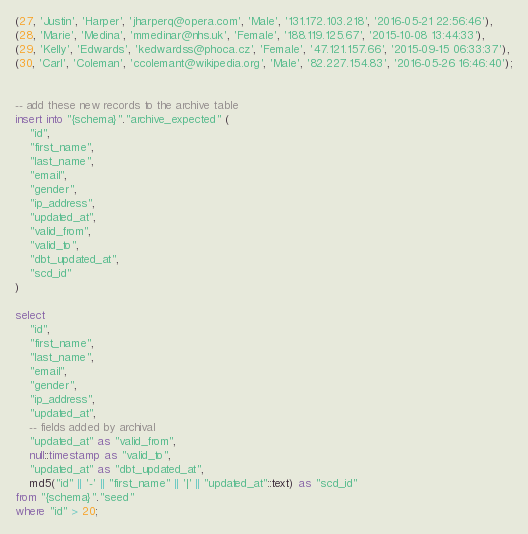Convert code to text. <code><loc_0><loc_0><loc_500><loc_500><_SQL_>(27, 'Justin', 'Harper', 'jharperq@opera.com', 'Male', '131.172.103.218', '2016-05-21 22:56:46'),
(28, 'Marie', 'Medina', 'mmedinar@nhs.uk', 'Female', '188.119.125.67', '2015-10-08 13:44:33'),
(29, 'Kelly', 'Edwards', 'kedwardss@phoca.cz', 'Female', '47.121.157.66', '2015-09-15 06:33:37'),
(30, 'Carl', 'Coleman', 'ccolemant@wikipedia.org', 'Male', '82.227.154.83', '2016-05-26 16:46:40');


-- add these new records to the archive table
insert into "{schema}"."archive_expected" (
    "id",
    "first_name",
    "last_name",
    "email",
    "gender",
    "ip_address",
    "updated_at",
    "valid_from",
    "valid_to",
    "dbt_updated_at",
    "scd_id"
)

select
    "id",
    "first_name",
    "last_name",
    "email",
    "gender",
    "ip_address",
    "updated_at",
    -- fields added by archival
    "updated_at" as "valid_from",
    null::timestamp as "valid_to",
    "updated_at" as "dbt_updated_at",
    md5("id" || '-' || "first_name" || '|' || "updated_at"::text) as "scd_id"
from "{schema}"."seed"
where "id" > 20;
</code> 